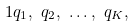<formula> <loc_0><loc_0><loc_500><loc_500>1 & q _ { 1 } , \ q _ { 2 } , \ \dots , \ q _ { K } ,</formula> 